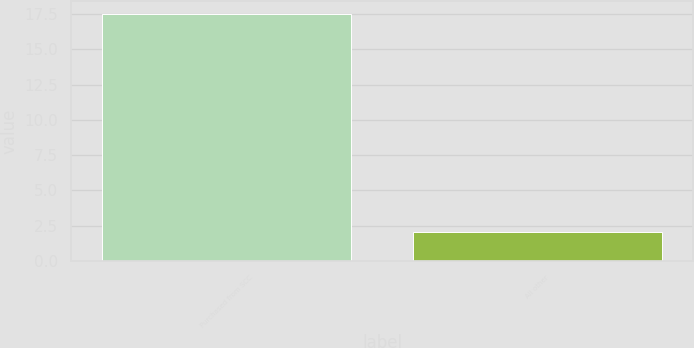<chart> <loc_0><loc_0><loc_500><loc_500><bar_chart><fcel>Purchased from SCC<fcel>All other<nl><fcel>17.53<fcel>2.07<nl></chart> 